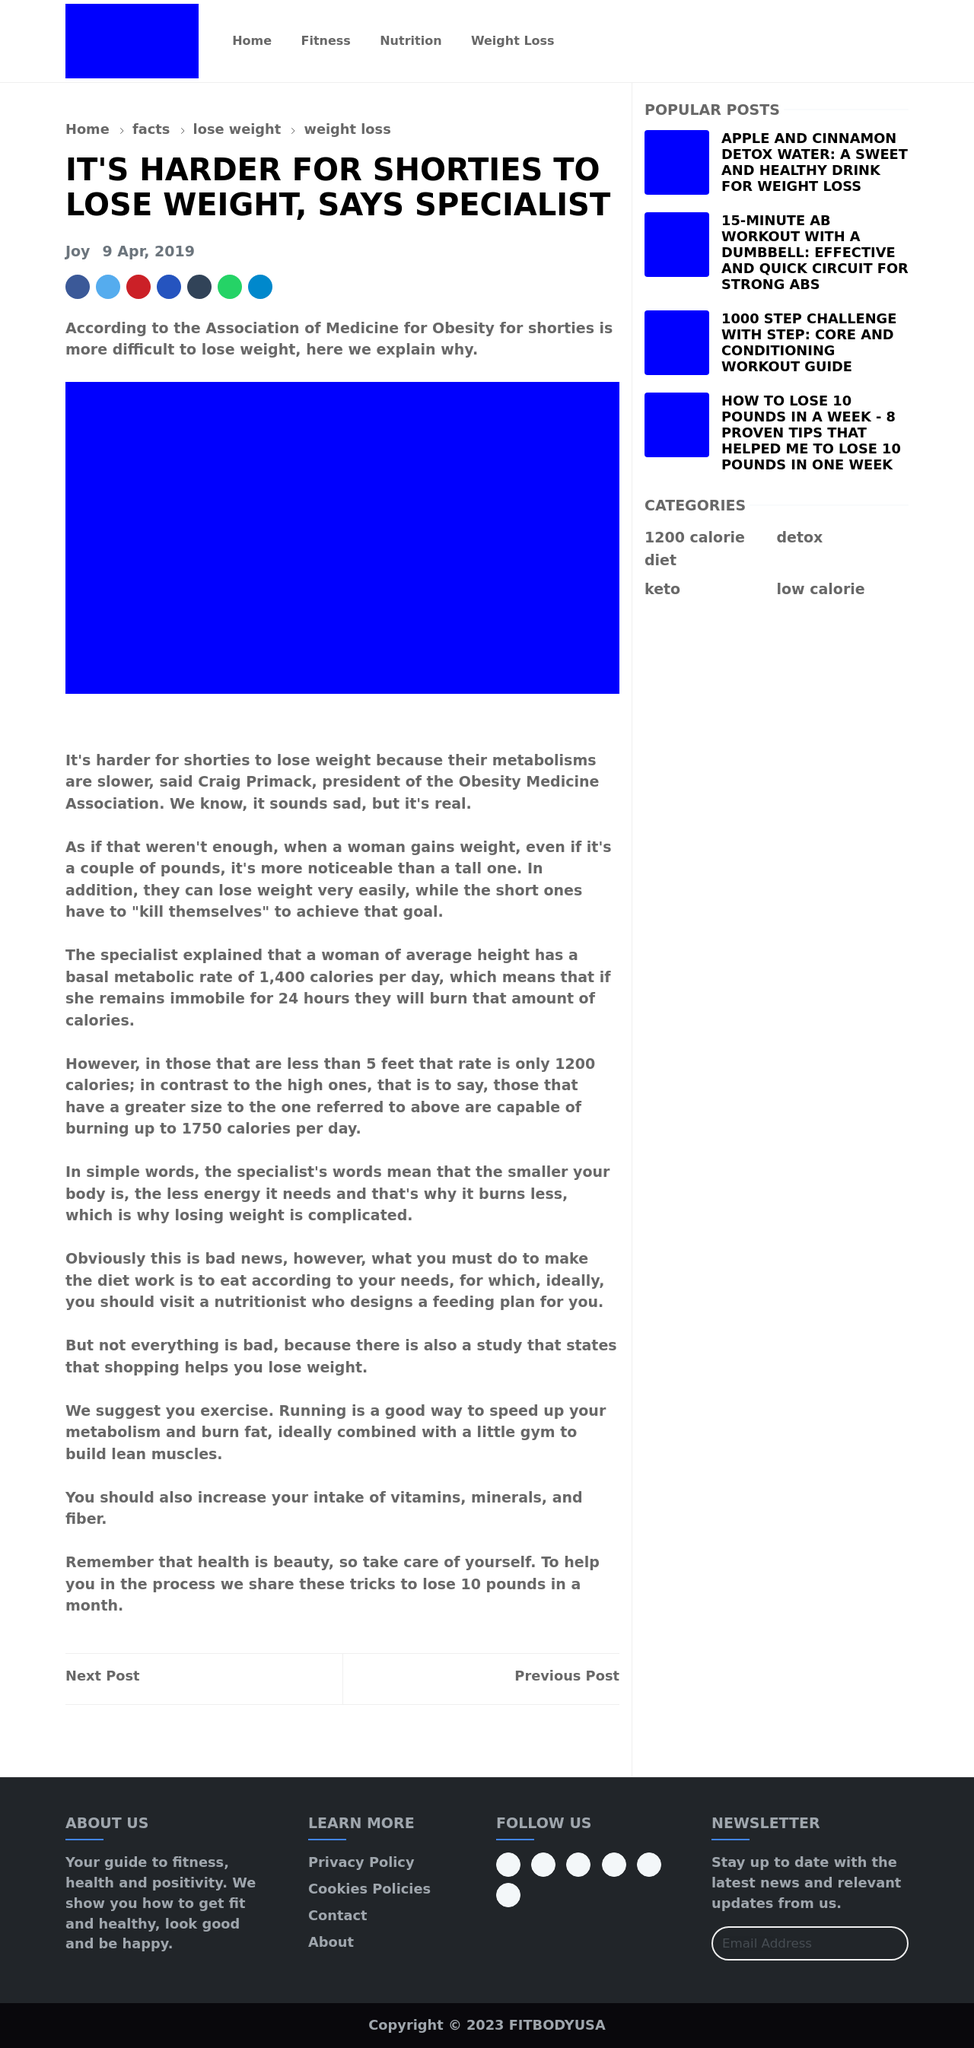Could you guide me through the process of developing this website with HTML? To develop a website similar to the one shown in the image, you'll need to start by understanding the basic structure of an HTML document, which includes tags for the header, title, body, and footer sections. Start with the <!DOCTYPE html> declaration to define the document type. Create the HTML container and define the head section including metadata, style (CSS for layout/styling), and the body of your webpage where all visible content goes. Use div tags to create sections (header, main content, sidebar), use the nav tag for navigation links. Apply styles using CSS for colors, fonts, and layout to match your design needs. Lastly, test your website in different browsers to ensure compatibility. To dive deeper, consider adding interactivity with JavaScript or improving accessibility and SEO. Remember, building a website is an iterative process! 